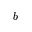Convert formula to latex. <formula><loc_0><loc_0><loc_500><loc_500>b</formula> 